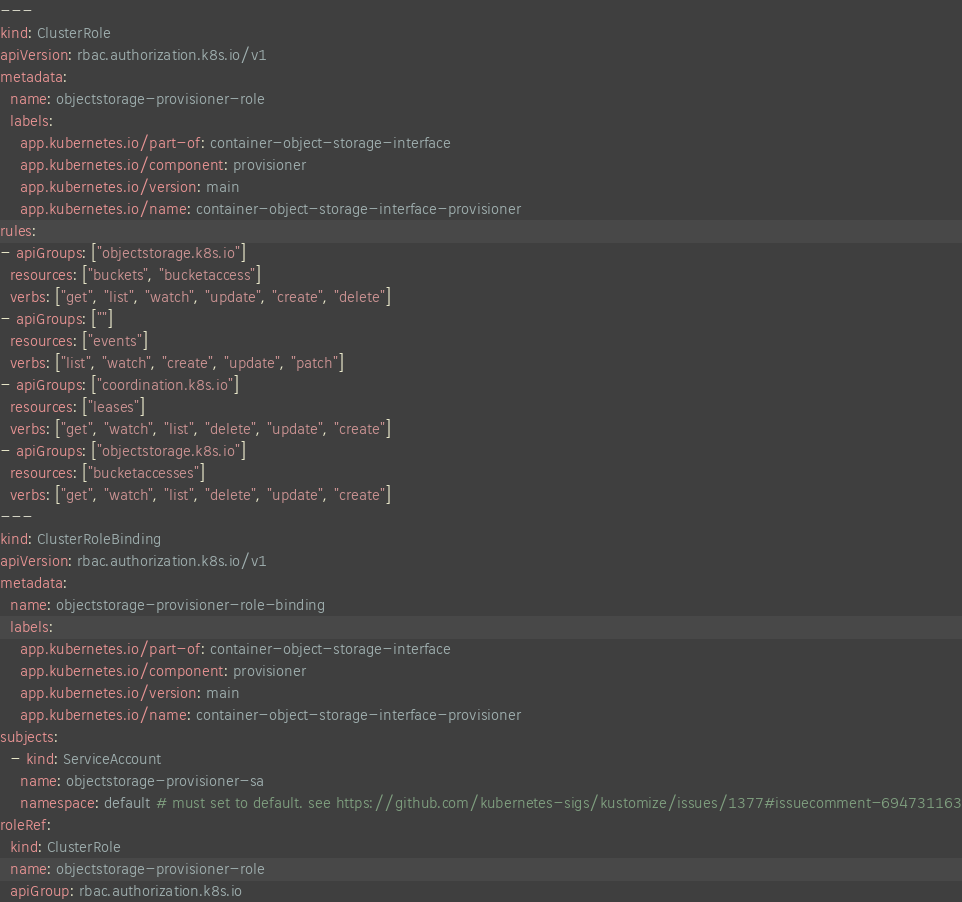Convert code to text. <code><loc_0><loc_0><loc_500><loc_500><_YAML_>---
kind: ClusterRole
apiVersion: rbac.authorization.k8s.io/v1
metadata:
  name: objectstorage-provisioner-role
  labels:
    app.kubernetes.io/part-of: container-object-storage-interface
    app.kubernetes.io/component: provisioner
    app.kubernetes.io/version: main
    app.kubernetes.io/name: container-object-storage-interface-provisioner
rules:
- apiGroups: ["objectstorage.k8s.io"]
  resources: ["buckets", "bucketaccess"]
  verbs: ["get", "list", "watch", "update", "create", "delete"]
- apiGroups: [""]
  resources: ["events"]
  verbs: ["list", "watch", "create", "update", "patch"]
- apiGroups: ["coordination.k8s.io"]
  resources: ["leases"]
  verbs: ["get", "watch", "list", "delete", "update", "create"]
- apiGroups: ["objectstorage.k8s.io"]
  resources: ["bucketaccesses"]
  verbs: ["get", "watch", "list", "delete", "update", "create"]
---
kind: ClusterRoleBinding
apiVersion: rbac.authorization.k8s.io/v1
metadata:
  name: objectstorage-provisioner-role-binding
  labels:
    app.kubernetes.io/part-of: container-object-storage-interface
    app.kubernetes.io/component: provisioner
    app.kubernetes.io/version: main
    app.kubernetes.io/name: container-object-storage-interface-provisioner
subjects:
  - kind: ServiceAccount
    name: objectstorage-provisioner-sa
    namespace: default # must set to default. see https://github.com/kubernetes-sigs/kustomize/issues/1377#issuecomment-694731163
roleRef:
  kind: ClusterRole
  name: objectstorage-provisioner-role
  apiGroup: rbac.authorization.k8s.io
</code> 